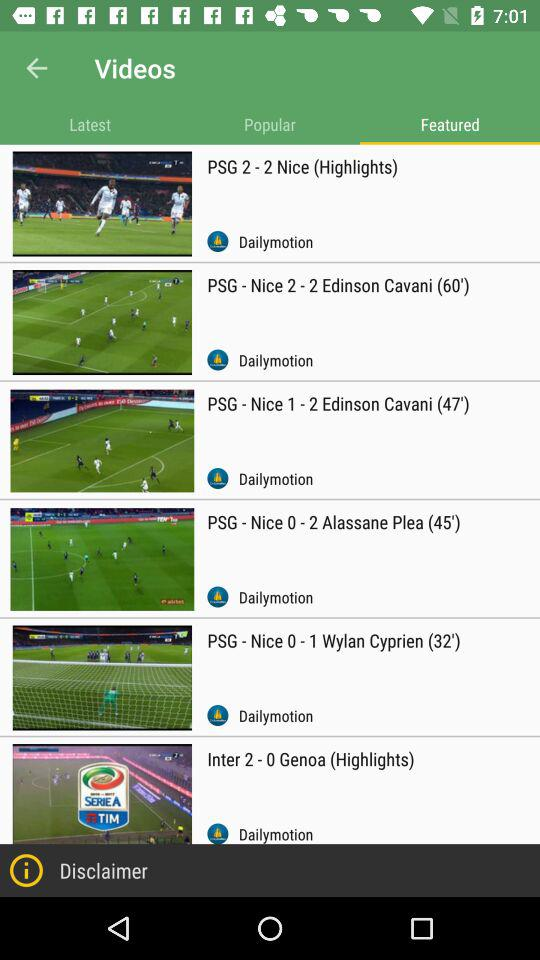What are the latest videos?
When the provided information is insufficient, respond with <no answer>. <no answer> 